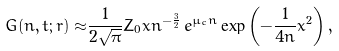Convert formula to latex. <formula><loc_0><loc_0><loc_500><loc_500>G ( n , t ; r ) \approx & \frac { 1 } { 2 \sqrt { \pi } } Z _ { 0 } x n ^ { - \frac { 3 } { 2 } } \, e ^ { \mu _ { c } n } \exp \left ( - \frac { 1 } { 4 n } x ^ { 2 } \right ) ,</formula> 